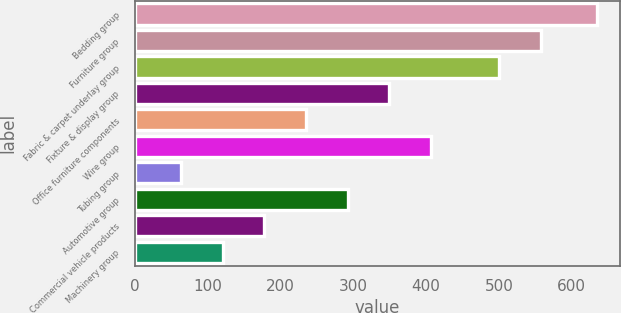<chart> <loc_0><loc_0><loc_500><loc_500><bar_chart><fcel>Bedding group<fcel>Furniture group<fcel>Fabric & carpet underlay group<fcel>Fixture & display group<fcel>Office furniture components<fcel>Wire group<fcel>Tubing group<fcel>Automotive group<fcel>Commercial vehicle products<fcel>Machinery group<nl><fcel>635.1<fcel>557.28<fcel>500.1<fcel>349.2<fcel>234.84<fcel>406.38<fcel>63.3<fcel>292.02<fcel>177.66<fcel>120.48<nl></chart> 